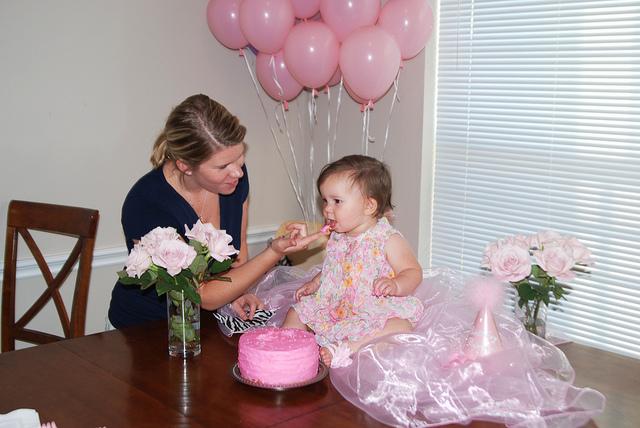Which hand is the mother using to touch the baby?
Be succinct. Right. What are they celebrating?
Give a very brief answer. Birthday. Does the dress have lace on it?
Be succinct. No. What color is the babies dress?
Concise answer only. Pink. 